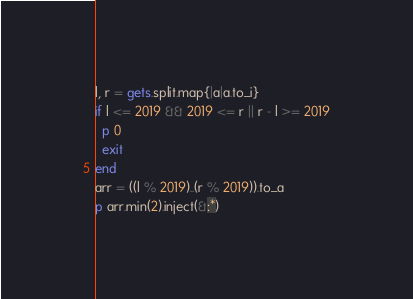Convert code to text. <code><loc_0><loc_0><loc_500><loc_500><_Ruby_>l, r = gets.split.map{|a|a.to_i}
if l <= 2019 && 2019 <= r || r - l >= 2019
  p 0
  exit
end
arr = ((l % 2019)..(r % 2019)).to_a
p arr.min(2).inject(&:*)
</code> 